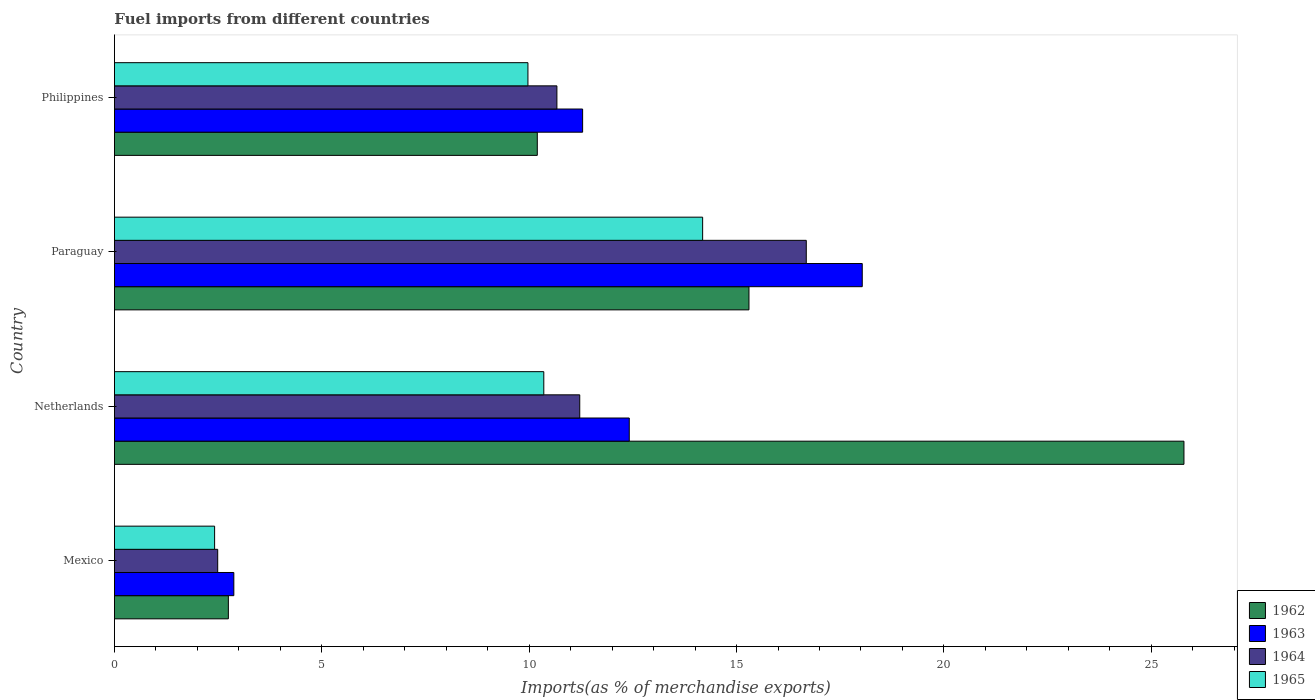How many different coloured bars are there?
Ensure brevity in your answer.  4. How many groups of bars are there?
Provide a succinct answer. 4. Are the number of bars on each tick of the Y-axis equal?
Offer a terse response. Yes. How many bars are there on the 2nd tick from the top?
Provide a short and direct response. 4. How many bars are there on the 4th tick from the bottom?
Make the answer very short. 4. What is the percentage of imports to different countries in 1962 in Netherlands?
Your answer should be very brief. 25.79. Across all countries, what is the maximum percentage of imports to different countries in 1963?
Offer a terse response. 18.03. Across all countries, what is the minimum percentage of imports to different countries in 1963?
Provide a short and direct response. 2.88. In which country was the percentage of imports to different countries in 1965 maximum?
Offer a terse response. Paraguay. What is the total percentage of imports to different countries in 1965 in the graph?
Your answer should be compact. 36.92. What is the difference between the percentage of imports to different countries in 1963 in Paraguay and that in Philippines?
Your response must be concise. 6.74. What is the difference between the percentage of imports to different countries in 1963 in Mexico and the percentage of imports to different countries in 1962 in Paraguay?
Your answer should be very brief. -12.42. What is the average percentage of imports to different countries in 1965 per country?
Offer a very short reply. 9.23. What is the difference between the percentage of imports to different countries in 1965 and percentage of imports to different countries in 1963 in Philippines?
Make the answer very short. -1.32. What is the ratio of the percentage of imports to different countries in 1964 in Netherlands to that in Paraguay?
Your answer should be very brief. 0.67. What is the difference between the highest and the second highest percentage of imports to different countries in 1964?
Make the answer very short. 5.46. What is the difference between the highest and the lowest percentage of imports to different countries in 1962?
Your response must be concise. 23.04. In how many countries, is the percentage of imports to different countries in 1963 greater than the average percentage of imports to different countries in 1963 taken over all countries?
Offer a terse response. 3. Is the sum of the percentage of imports to different countries in 1965 in Netherlands and Paraguay greater than the maximum percentage of imports to different countries in 1962 across all countries?
Your response must be concise. No. Is it the case that in every country, the sum of the percentage of imports to different countries in 1964 and percentage of imports to different countries in 1965 is greater than the sum of percentage of imports to different countries in 1962 and percentage of imports to different countries in 1963?
Provide a short and direct response. No. What does the 1st bar from the bottom in Mexico represents?
Your response must be concise. 1962. What is the difference between two consecutive major ticks on the X-axis?
Your answer should be compact. 5. Does the graph contain grids?
Provide a succinct answer. No. How are the legend labels stacked?
Offer a terse response. Vertical. What is the title of the graph?
Your answer should be very brief. Fuel imports from different countries. Does "1970" appear as one of the legend labels in the graph?
Your answer should be compact. No. What is the label or title of the X-axis?
Your response must be concise. Imports(as % of merchandise exports). What is the Imports(as % of merchandise exports) of 1962 in Mexico?
Your answer should be very brief. 2.75. What is the Imports(as % of merchandise exports) in 1963 in Mexico?
Your response must be concise. 2.88. What is the Imports(as % of merchandise exports) in 1964 in Mexico?
Offer a terse response. 2.49. What is the Imports(as % of merchandise exports) of 1965 in Mexico?
Ensure brevity in your answer.  2.42. What is the Imports(as % of merchandise exports) of 1962 in Netherlands?
Provide a succinct answer. 25.79. What is the Imports(as % of merchandise exports) in 1963 in Netherlands?
Ensure brevity in your answer.  12.41. What is the Imports(as % of merchandise exports) of 1964 in Netherlands?
Your answer should be compact. 11.22. What is the Imports(as % of merchandise exports) in 1965 in Netherlands?
Ensure brevity in your answer.  10.35. What is the Imports(as % of merchandise exports) in 1962 in Paraguay?
Provide a short and direct response. 15.3. What is the Imports(as % of merchandise exports) in 1963 in Paraguay?
Your response must be concise. 18.03. What is the Imports(as % of merchandise exports) in 1964 in Paraguay?
Offer a very short reply. 16.68. What is the Imports(as % of merchandise exports) in 1965 in Paraguay?
Give a very brief answer. 14.18. What is the Imports(as % of merchandise exports) of 1962 in Philippines?
Provide a succinct answer. 10.2. What is the Imports(as % of merchandise exports) in 1963 in Philippines?
Offer a terse response. 11.29. What is the Imports(as % of merchandise exports) of 1964 in Philippines?
Give a very brief answer. 10.67. What is the Imports(as % of merchandise exports) in 1965 in Philippines?
Provide a succinct answer. 9.97. Across all countries, what is the maximum Imports(as % of merchandise exports) of 1962?
Give a very brief answer. 25.79. Across all countries, what is the maximum Imports(as % of merchandise exports) in 1963?
Your response must be concise. 18.03. Across all countries, what is the maximum Imports(as % of merchandise exports) of 1964?
Ensure brevity in your answer.  16.68. Across all countries, what is the maximum Imports(as % of merchandise exports) of 1965?
Provide a succinct answer. 14.18. Across all countries, what is the minimum Imports(as % of merchandise exports) of 1962?
Your response must be concise. 2.75. Across all countries, what is the minimum Imports(as % of merchandise exports) of 1963?
Your answer should be compact. 2.88. Across all countries, what is the minimum Imports(as % of merchandise exports) of 1964?
Make the answer very short. 2.49. Across all countries, what is the minimum Imports(as % of merchandise exports) of 1965?
Provide a succinct answer. 2.42. What is the total Imports(as % of merchandise exports) in 1962 in the graph?
Give a very brief answer. 54.03. What is the total Imports(as % of merchandise exports) of 1963 in the graph?
Provide a succinct answer. 44.61. What is the total Imports(as % of merchandise exports) in 1964 in the graph?
Offer a very short reply. 41.06. What is the total Imports(as % of merchandise exports) of 1965 in the graph?
Your response must be concise. 36.92. What is the difference between the Imports(as % of merchandise exports) in 1962 in Mexico and that in Netherlands?
Provide a short and direct response. -23.04. What is the difference between the Imports(as % of merchandise exports) of 1963 in Mexico and that in Netherlands?
Offer a very short reply. -9.53. What is the difference between the Imports(as % of merchandise exports) in 1964 in Mexico and that in Netherlands?
Your response must be concise. -8.73. What is the difference between the Imports(as % of merchandise exports) in 1965 in Mexico and that in Netherlands?
Ensure brevity in your answer.  -7.94. What is the difference between the Imports(as % of merchandise exports) in 1962 in Mexico and that in Paraguay?
Offer a terse response. -12.55. What is the difference between the Imports(as % of merchandise exports) of 1963 in Mexico and that in Paraguay?
Give a very brief answer. -15.15. What is the difference between the Imports(as % of merchandise exports) of 1964 in Mexico and that in Paraguay?
Offer a very short reply. -14.19. What is the difference between the Imports(as % of merchandise exports) of 1965 in Mexico and that in Paraguay?
Your response must be concise. -11.77. What is the difference between the Imports(as % of merchandise exports) of 1962 in Mexico and that in Philippines?
Give a very brief answer. -7.45. What is the difference between the Imports(as % of merchandise exports) of 1963 in Mexico and that in Philippines?
Offer a very short reply. -8.41. What is the difference between the Imports(as % of merchandise exports) in 1964 in Mexico and that in Philippines?
Provide a succinct answer. -8.18. What is the difference between the Imports(as % of merchandise exports) in 1965 in Mexico and that in Philippines?
Offer a terse response. -7.55. What is the difference between the Imports(as % of merchandise exports) in 1962 in Netherlands and that in Paraguay?
Ensure brevity in your answer.  10.49. What is the difference between the Imports(as % of merchandise exports) of 1963 in Netherlands and that in Paraguay?
Give a very brief answer. -5.62. What is the difference between the Imports(as % of merchandise exports) of 1964 in Netherlands and that in Paraguay?
Keep it short and to the point. -5.46. What is the difference between the Imports(as % of merchandise exports) in 1965 in Netherlands and that in Paraguay?
Ensure brevity in your answer.  -3.83. What is the difference between the Imports(as % of merchandise exports) in 1962 in Netherlands and that in Philippines?
Your answer should be very brief. 15.59. What is the difference between the Imports(as % of merchandise exports) in 1963 in Netherlands and that in Philippines?
Offer a terse response. 1.12. What is the difference between the Imports(as % of merchandise exports) in 1964 in Netherlands and that in Philippines?
Offer a very short reply. 0.55. What is the difference between the Imports(as % of merchandise exports) in 1965 in Netherlands and that in Philippines?
Your answer should be very brief. 0.38. What is the difference between the Imports(as % of merchandise exports) of 1962 in Paraguay and that in Philippines?
Offer a very short reply. 5.1. What is the difference between the Imports(as % of merchandise exports) in 1963 in Paraguay and that in Philippines?
Offer a very short reply. 6.74. What is the difference between the Imports(as % of merchandise exports) in 1964 in Paraguay and that in Philippines?
Offer a terse response. 6.01. What is the difference between the Imports(as % of merchandise exports) in 1965 in Paraguay and that in Philippines?
Your response must be concise. 4.21. What is the difference between the Imports(as % of merchandise exports) in 1962 in Mexico and the Imports(as % of merchandise exports) in 1963 in Netherlands?
Keep it short and to the point. -9.67. What is the difference between the Imports(as % of merchandise exports) of 1962 in Mexico and the Imports(as % of merchandise exports) of 1964 in Netherlands?
Make the answer very short. -8.47. What is the difference between the Imports(as % of merchandise exports) of 1962 in Mexico and the Imports(as % of merchandise exports) of 1965 in Netherlands?
Offer a very short reply. -7.61. What is the difference between the Imports(as % of merchandise exports) in 1963 in Mexico and the Imports(as % of merchandise exports) in 1964 in Netherlands?
Offer a very short reply. -8.34. What is the difference between the Imports(as % of merchandise exports) in 1963 in Mexico and the Imports(as % of merchandise exports) in 1965 in Netherlands?
Your answer should be compact. -7.47. What is the difference between the Imports(as % of merchandise exports) in 1964 in Mexico and the Imports(as % of merchandise exports) in 1965 in Netherlands?
Offer a very short reply. -7.86. What is the difference between the Imports(as % of merchandise exports) in 1962 in Mexico and the Imports(as % of merchandise exports) in 1963 in Paraguay?
Ensure brevity in your answer.  -15.28. What is the difference between the Imports(as % of merchandise exports) of 1962 in Mexico and the Imports(as % of merchandise exports) of 1964 in Paraguay?
Offer a terse response. -13.93. What is the difference between the Imports(as % of merchandise exports) of 1962 in Mexico and the Imports(as % of merchandise exports) of 1965 in Paraguay?
Your answer should be very brief. -11.44. What is the difference between the Imports(as % of merchandise exports) of 1963 in Mexico and the Imports(as % of merchandise exports) of 1964 in Paraguay?
Make the answer very short. -13.8. What is the difference between the Imports(as % of merchandise exports) in 1963 in Mexico and the Imports(as % of merchandise exports) in 1965 in Paraguay?
Give a very brief answer. -11.3. What is the difference between the Imports(as % of merchandise exports) in 1964 in Mexico and the Imports(as % of merchandise exports) in 1965 in Paraguay?
Make the answer very short. -11.69. What is the difference between the Imports(as % of merchandise exports) in 1962 in Mexico and the Imports(as % of merchandise exports) in 1963 in Philippines?
Provide a short and direct response. -8.54. What is the difference between the Imports(as % of merchandise exports) in 1962 in Mexico and the Imports(as % of merchandise exports) in 1964 in Philippines?
Offer a very short reply. -7.92. What is the difference between the Imports(as % of merchandise exports) of 1962 in Mexico and the Imports(as % of merchandise exports) of 1965 in Philippines?
Offer a terse response. -7.22. What is the difference between the Imports(as % of merchandise exports) in 1963 in Mexico and the Imports(as % of merchandise exports) in 1964 in Philippines?
Give a very brief answer. -7.79. What is the difference between the Imports(as % of merchandise exports) in 1963 in Mexico and the Imports(as % of merchandise exports) in 1965 in Philippines?
Your response must be concise. -7.09. What is the difference between the Imports(as % of merchandise exports) of 1964 in Mexico and the Imports(as % of merchandise exports) of 1965 in Philippines?
Ensure brevity in your answer.  -7.48. What is the difference between the Imports(as % of merchandise exports) in 1962 in Netherlands and the Imports(as % of merchandise exports) in 1963 in Paraguay?
Keep it short and to the point. 7.76. What is the difference between the Imports(as % of merchandise exports) of 1962 in Netherlands and the Imports(as % of merchandise exports) of 1964 in Paraguay?
Keep it short and to the point. 9.11. What is the difference between the Imports(as % of merchandise exports) of 1962 in Netherlands and the Imports(as % of merchandise exports) of 1965 in Paraguay?
Provide a short and direct response. 11.6. What is the difference between the Imports(as % of merchandise exports) of 1963 in Netherlands and the Imports(as % of merchandise exports) of 1964 in Paraguay?
Your answer should be compact. -4.27. What is the difference between the Imports(as % of merchandise exports) in 1963 in Netherlands and the Imports(as % of merchandise exports) in 1965 in Paraguay?
Keep it short and to the point. -1.77. What is the difference between the Imports(as % of merchandise exports) of 1964 in Netherlands and the Imports(as % of merchandise exports) of 1965 in Paraguay?
Provide a short and direct response. -2.96. What is the difference between the Imports(as % of merchandise exports) of 1962 in Netherlands and the Imports(as % of merchandise exports) of 1963 in Philippines?
Give a very brief answer. 14.5. What is the difference between the Imports(as % of merchandise exports) of 1962 in Netherlands and the Imports(as % of merchandise exports) of 1964 in Philippines?
Keep it short and to the point. 15.12. What is the difference between the Imports(as % of merchandise exports) of 1962 in Netherlands and the Imports(as % of merchandise exports) of 1965 in Philippines?
Provide a succinct answer. 15.82. What is the difference between the Imports(as % of merchandise exports) of 1963 in Netherlands and the Imports(as % of merchandise exports) of 1964 in Philippines?
Offer a very short reply. 1.74. What is the difference between the Imports(as % of merchandise exports) in 1963 in Netherlands and the Imports(as % of merchandise exports) in 1965 in Philippines?
Offer a very short reply. 2.44. What is the difference between the Imports(as % of merchandise exports) of 1964 in Netherlands and the Imports(as % of merchandise exports) of 1965 in Philippines?
Offer a terse response. 1.25. What is the difference between the Imports(as % of merchandise exports) in 1962 in Paraguay and the Imports(as % of merchandise exports) in 1963 in Philippines?
Keep it short and to the point. 4.01. What is the difference between the Imports(as % of merchandise exports) in 1962 in Paraguay and the Imports(as % of merchandise exports) in 1964 in Philippines?
Ensure brevity in your answer.  4.63. What is the difference between the Imports(as % of merchandise exports) of 1962 in Paraguay and the Imports(as % of merchandise exports) of 1965 in Philippines?
Your response must be concise. 5.33. What is the difference between the Imports(as % of merchandise exports) of 1963 in Paraguay and the Imports(as % of merchandise exports) of 1964 in Philippines?
Ensure brevity in your answer.  7.36. What is the difference between the Imports(as % of merchandise exports) in 1963 in Paraguay and the Imports(as % of merchandise exports) in 1965 in Philippines?
Offer a terse response. 8.06. What is the difference between the Imports(as % of merchandise exports) of 1964 in Paraguay and the Imports(as % of merchandise exports) of 1965 in Philippines?
Offer a terse response. 6.71. What is the average Imports(as % of merchandise exports) in 1962 per country?
Make the answer very short. 13.51. What is the average Imports(as % of merchandise exports) in 1963 per country?
Offer a very short reply. 11.15. What is the average Imports(as % of merchandise exports) of 1964 per country?
Make the answer very short. 10.26. What is the average Imports(as % of merchandise exports) in 1965 per country?
Provide a succinct answer. 9.23. What is the difference between the Imports(as % of merchandise exports) in 1962 and Imports(as % of merchandise exports) in 1963 in Mexico?
Offer a very short reply. -0.13. What is the difference between the Imports(as % of merchandise exports) in 1962 and Imports(as % of merchandise exports) in 1964 in Mexico?
Ensure brevity in your answer.  0.26. What is the difference between the Imports(as % of merchandise exports) in 1962 and Imports(as % of merchandise exports) in 1965 in Mexico?
Your answer should be compact. 0.33. What is the difference between the Imports(as % of merchandise exports) of 1963 and Imports(as % of merchandise exports) of 1964 in Mexico?
Your answer should be compact. 0.39. What is the difference between the Imports(as % of merchandise exports) of 1963 and Imports(as % of merchandise exports) of 1965 in Mexico?
Make the answer very short. 0.46. What is the difference between the Imports(as % of merchandise exports) of 1964 and Imports(as % of merchandise exports) of 1965 in Mexico?
Offer a terse response. 0.07. What is the difference between the Imports(as % of merchandise exports) of 1962 and Imports(as % of merchandise exports) of 1963 in Netherlands?
Offer a terse response. 13.37. What is the difference between the Imports(as % of merchandise exports) in 1962 and Imports(as % of merchandise exports) in 1964 in Netherlands?
Make the answer very short. 14.57. What is the difference between the Imports(as % of merchandise exports) in 1962 and Imports(as % of merchandise exports) in 1965 in Netherlands?
Your answer should be compact. 15.43. What is the difference between the Imports(as % of merchandise exports) in 1963 and Imports(as % of merchandise exports) in 1964 in Netherlands?
Make the answer very short. 1.19. What is the difference between the Imports(as % of merchandise exports) in 1963 and Imports(as % of merchandise exports) in 1965 in Netherlands?
Provide a short and direct response. 2.06. What is the difference between the Imports(as % of merchandise exports) of 1964 and Imports(as % of merchandise exports) of 1965 in Netherlands?
Your response must be concise. 0.87. What is the difference between the Imports(as % of merchandise exports) of 1962 and Imports(as % of merchandise exports) of 1963 in Paraguay?
Provide a succinct answer. -2.73. What is the difference between the Imports(as % of merchandise exports) of 1962 and Imports(as % of merchandise exports) of 1964 in Paraguay?
Provide a short and direct response. -1.38. What is the difference between the Imports(as % of merchandise exports) in 1962 and Imports(as % of merchandise exports) in 1965 in Paraguay?
Your answer should be compact. 1.12. What is the difference between the Imports(as % of merchandise exports) of 1963 and Imports(as % of merchandise exports) of 1964 in Paraguay?
Your answer should be very brief. 1.35. What is the difference between the Imports(as % of merchandise exports) in 1963 and Imports(as % of merchandise exports) in 1965 in Paraguay?
Provide a short and direct response. 3.85. What is the difference between the Imports(as % of merchandise exports) of 1964 and Imports(as % of merchandise exports) of 1965 in Paraguay?
Make the answer very short. 2.5. What is the difference between the Imports(as % of merchandise exports) of 1962 and Imports(as % of merchandise exports) of 1963 in Philippines?
Provide a short and direct response. -1.09. What is the difference between the Imports(as % of merchandise exports) in 1962 and Imports(as % of merchandise exports) in 1964 in Philippines?
Keep it short and to the point. -0.47. What is the difference between the Imports(as % of merchandise exports) of 1962 and Imports(as % of merchandise exports) of 1965 in Philippines?
Keep it short and to the point. 0.23. What is the difference between the Imports(as % of merchandise exports) in 1963 and Imports(as % of merchandise exports) in 1964 in Philippines?
Your answer should be compact. 0.62. What is the difference between the Imports(as % of merchandise exports) in 1963 and Imports(as % of merchandise exports) in 1965 in Philippines?
Your response must be concise. 1.32. What is the difference between the Imports(as % of merchandise exports) of 1964 and Imports(as % of merchandise exports) of 1965 in Philippines?
Offer a terse response. 0.7. What is the ratio of the Imports(as % of merchandise exports) of 1962 in Mexico to that in Netherlands?
Your answer should be compact. 0.11. What is the ratio of the Imports(as % of merchandise exports) in 1963 in Mexico to that in Netherlands?
Make the answer very short. 0.23. What is the ratio of the Imports(as % of merchandise exports) of 1964 in Mexico to that in Netherlands?
Offer a very short reply. 0.22. What is the ratio of the Imports(as % of merchandise exports) of 1965 in Mexico to that in Netherlands?
Your answer should be compact. 0.23. What is the ratio of the Imports(as % of merchandise exports) of 1962 in Mexico to that in Paraguay?
Your answer should be very brief. 0.18. What is the ratio of the Imports(as % of merchandise exports) of 1963 in Mexico to that in Paraguay?
Offer a very short reply. 0.16. What is the ratio of the Imports(as % of merchandise exports) of 1964 in Mexico to that in Paraguay?
Offer a terse response. 0.15. What is the ratio of the Imports(as % of merchandise exports) of 1965 in Mexico to that in Paraguay?
Offer a terse response. 0.17. What is the ratio of the Imports(as % of merchandise exports) of 1962 in Mexico to that in Philippines?
Provide a succinct answer. 0.27. What is the ratio of the Imports(as % of merchandise exports) of 1963 in Mexico to that in Philippines?
Your answer should be compact. 0.26. What is the ratio of the Imports(as % of merchandise exports) of 1964 in Mexico to that in Philippines?
Offer a terse response. 0.23. What is the ratio of the Imports(as % of merchandise exports) of 1965 in Mexico to that in Philippines?
Provide a short and direct response. 0.24. What is the ratio of the Imports(as % of merchandise exports) in 1962 in Netherlands to that in Paraguay?
Your answer should be very brief. 1.69. What is the ratio of the Imports(as % of merchandise exports) in 1963 in Netherlands to that in Paraguay?
Offer a terse response. 0.69. What is the ratio of the Imports(as % of merchandise exports) in 1964 in Netherlands to that in Paraguay?
Your answer should be compact. 0.67. What is the ratio of the Imports(as % of merchandise exports) of 1965 in Netherlands to that in Paraguay?
Provide a succinct answer. 0.73. What is the ratio of the Imports(as % of merchandise exports) in 1962 in Netherlands to that in Philippines?
Your response must be concise. 2.53. What is the ratio of the Imports(as % of merchandise exports) of 1963 in Netherlands to that in Philippines?
Offer a very short reply. 1.1. What is the ratio of the Imports(as % of merchandise exports) in 1964 in Netherlands to that in Philippines?
Provide a short and direct response. 1.05. What is the ratio of the Imports(as % of merchandise exports) in 1965 in Netherlands to that in Philippines?
Keep it short and to the point. 1.04. What is the ratio of the Imports(as % of merchandise exports) of 1962 in Paraguay to that in Philippines?
Provide a short and direct response. 1.5. What is the ratio of the Imports(as % of merchandise exports) in 1963 in Paraguay to that in Philippines?
Keep it short and to the point. 1.6. What is the ratio of the Imports(as % of merchandise exports) in 1964 in Paraguay to that in Philippines?
Your answer should be very brief. 1.56. What is the ratio of the Imports(as % of merchandise exports) of 1965 in Paraguay to that in Philippines?
Your answer should be compact. 1.42. What is the difference between the highest and the second highest Imports(as % of merchandise exports) of 1962?
Offer a very short reply. 10.49. What is the difference between the highest and the second highest Imports(as % of merchandise exports) of 1963?
Give a very brief answer. 5.62. What is the difference between the highest and the second highest Imports(as % of merchandise exports) in 1964?
Provide a succinct answer. 5.46. What is the difference between the highest and the second highest Imports(as % of merchandise exports) in 1965?
Ensure brevity in your answer.  3.83. What is the difference between the highest and the lowest Imports(as % of merchandise exports) of 1962?
Make the answer very short. 23.04. What is the difference between the highest and the lowest Imports(as % of merchandise exports) in 1963?
Give a very brief answer. 15.15. What is the difference between the highest and the lowest Imports(as % of merchandise exports) in 1964?
Give a very brief answer. 14.19. What is the difference between the highest and the lowest Imports(as % of merchandise exports) of 1965?
Ensure brevity in your answer.  11.77. 